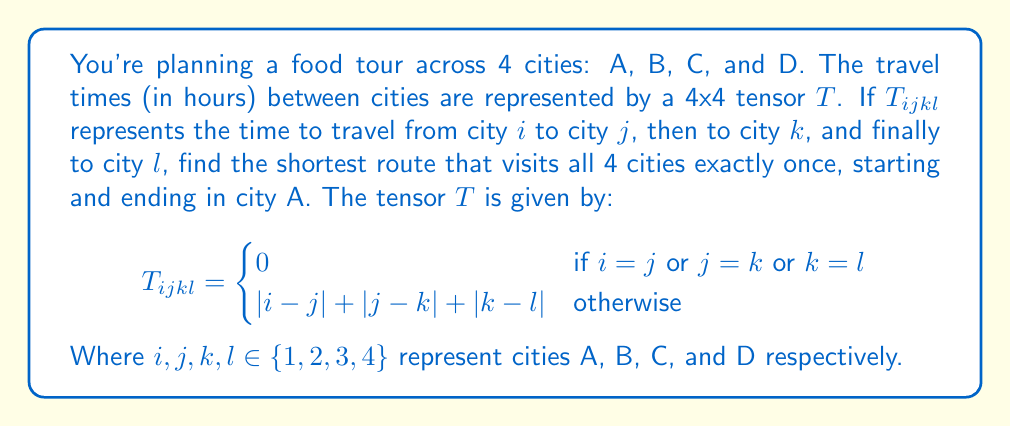Can you answer this question? Let's approach this step-by-step:

1) First, we need to understand what the tensor represents. $T_{ijkl}$ gives the total travel time for the route i → j → k → l.

2) We're looking for the shortest route that starts at A (1), visits B, C, and D in some order, and returns to A (1). There are 3! = 6 possible routes:

   1 → 2 → 3 → 4 → 1
   1 → 2 → 4 → 3 → 1
   1 → 3 → 2 → 4 → 1
   1 → 3 → 4 → 2 → 1
   1 → 4 → 2 → 3 → 1
   1 → 4 → 3 → 2 → 1

3) For each route, we need to calculate $T_{ijkl} + T_{l1}$. Let's do this for the first route:

   $T_{1234} = |1-2| + |2-3| + |3-4| = 1 + 1 + 1 = 3$
   $T_{41} = |4-1| = 3$
   Total = $3 + 3 = 6$

4) Let's calculate for all routes:

   1 → 2 → 3 → 4 → 1: $T_{1234} + T_{41} = 3 + 3 = 6$
   1 → 2 → 4 → 3 → 1: $T_{1243} + T_{31} = 4 + 2 = 6$
   1 → 3 → 2 → 4 → 1: $T_{1324} + T_{41} = 4 + 3 = 7$
   1 → 3 → 4 → 2 → 1: $T_{1342} + T_{21} = 5 + 1 = 6$
   1 → 4 → 2 → 3 → 1: $T_{1423} + T_{31} = 5 + 2 = 7$
   1 → 4 → 3 → 2 → 1: $T_{1432} + T_{21} = 4 + 1 = 5$

5) The shortest route is 1 → 4 → 3 → 2 → 1, with a total travel time of 5 hours.
Answer: A → D → C → B → A, 5 hours 